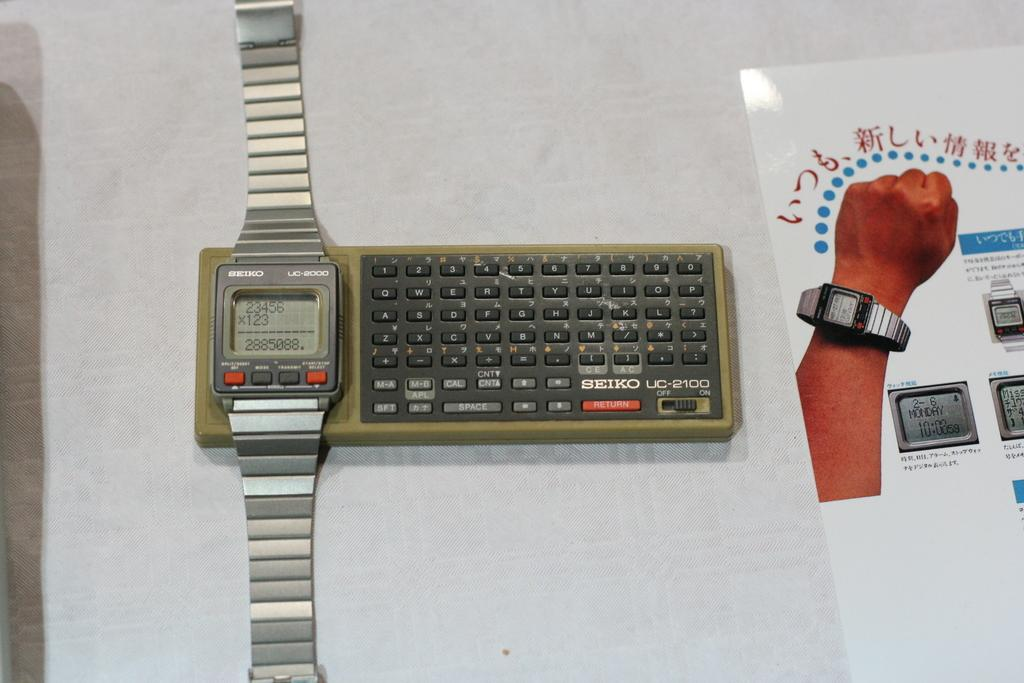<image>
Present a compact description of the photo's key features. A silver Seiko watch with a small Seiko keyboard to the right of it. 